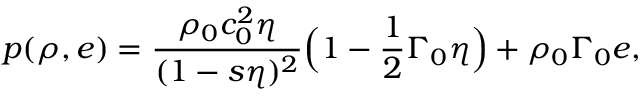<formula> <loc_0><loc_0><loc_500><loc_500>p ( \rho , e ) = \frac { \rho _ { 0 } c _ { 0 } ^ { 2 } \eta } { ( 1 - s \eta ) ^ { 2 } } \left ( 1 - \frac { 1 } { 2 } \Gamma _ { 0 } \eta \right ) + \rho _ { 0 } \Gamma _ { 0 } e ,</formula> 